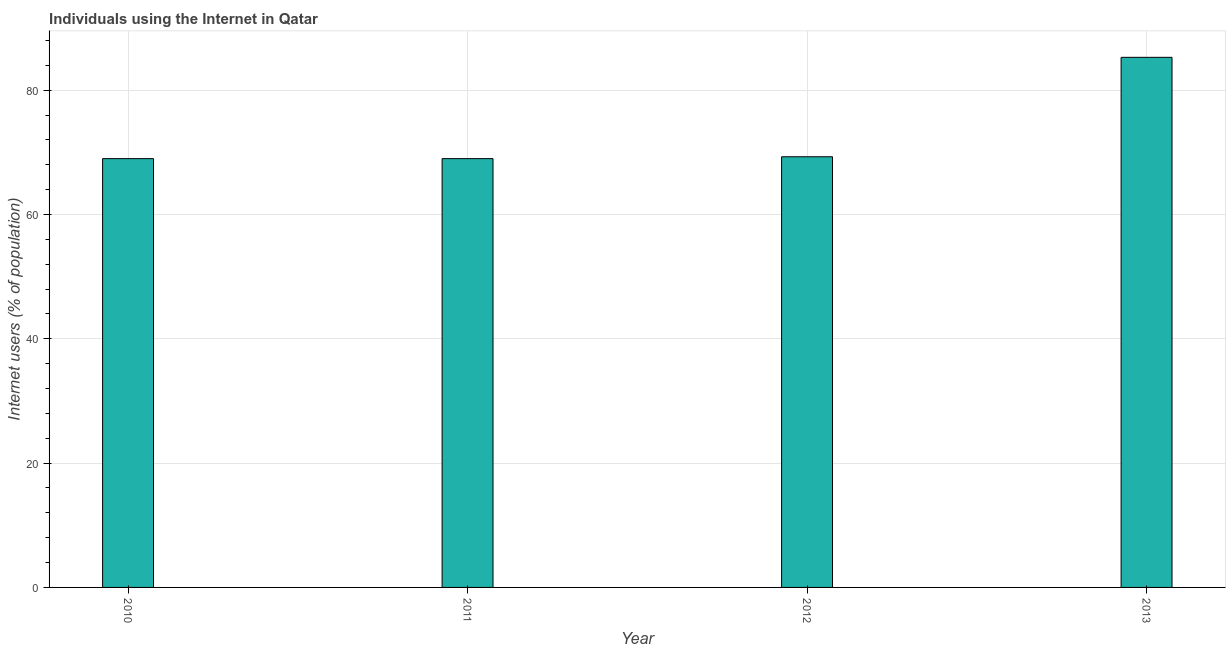Does the graph contain any zero values?
Give a very brief answer. No. What is the title of the graph?
Give a very brief answer. Individuals using the Internet in Qatar. What is the label or title of the Y-axis?
Offer a very short reply. Internet users (% of population). Across all years, what is the maximum number of internet users?
Give a very brief answer. 85.3. Across all years, what is the minimum number of internet users?
Offer a terse response. 69. In which year was the number of internet users maximum?
Your answer should be very brief. 2013. In which year was the number of internet users minimum?
Your response must be concise. 2010. What is the sum of the number of internet users?
Provide a short and direct response. 292.6. What is the difference between the number of internet users in 2012 and 2013?
Offer a terse response. -16. What is the average number of internet users per year?
Your response must be concise. 73.15. What is the median number of internet users?
Make the answer very short. 69.15. In how many years, is the number of internet users greater than 28 %?
Ensure brevity in your answer.  4. Is the number of internet users in 2011 less than that in 2012?
Provide a succinct answer. Yes. Is the sum of the number of internet users in 2011 and 2013 greater than the maximum number of internet users across all years?
Offer a terse response. Yes. What is the difference between the highest and the lowest number of internet users?
Offer a terse response. 16.3. How many bars are there?
Make the answer very short. 4. How many years are there in the graph?
Make the answer very short. 4. What is the Internet users (% of population) of 2011?
Provide a succinct answer. 69. What is the Internet users (% of population) of 2012?
Ensure brevity in your answer.  69.3. What is the Internet users (% of population) in 2013?
Make the answer very short. 85.3. What is the difference between the Internet users (% of population) in 2010 and 2013?
Provide a succinct answer. -16.3. What is the difference between the Internet users (% of population) in 2011 and 2013?
Your response must be concise. -16.3. What is the ratio of the Internet users (% of population) in 2010 to that in 2011?
Keep it short and to the point. 1. What is the ratio of the Internet users (% of population) in 2010 to that in 2013?
Ensure brevity in your answer.  0.81. What is the ratio of the Internet users (% of population) in 2011 to that in 2013?
Offer a terse response. 0.81. What is the ratio of the Internet users (% of population) in 2012 to that in 2013?
Ensure brevity in your answer.  0.81. 